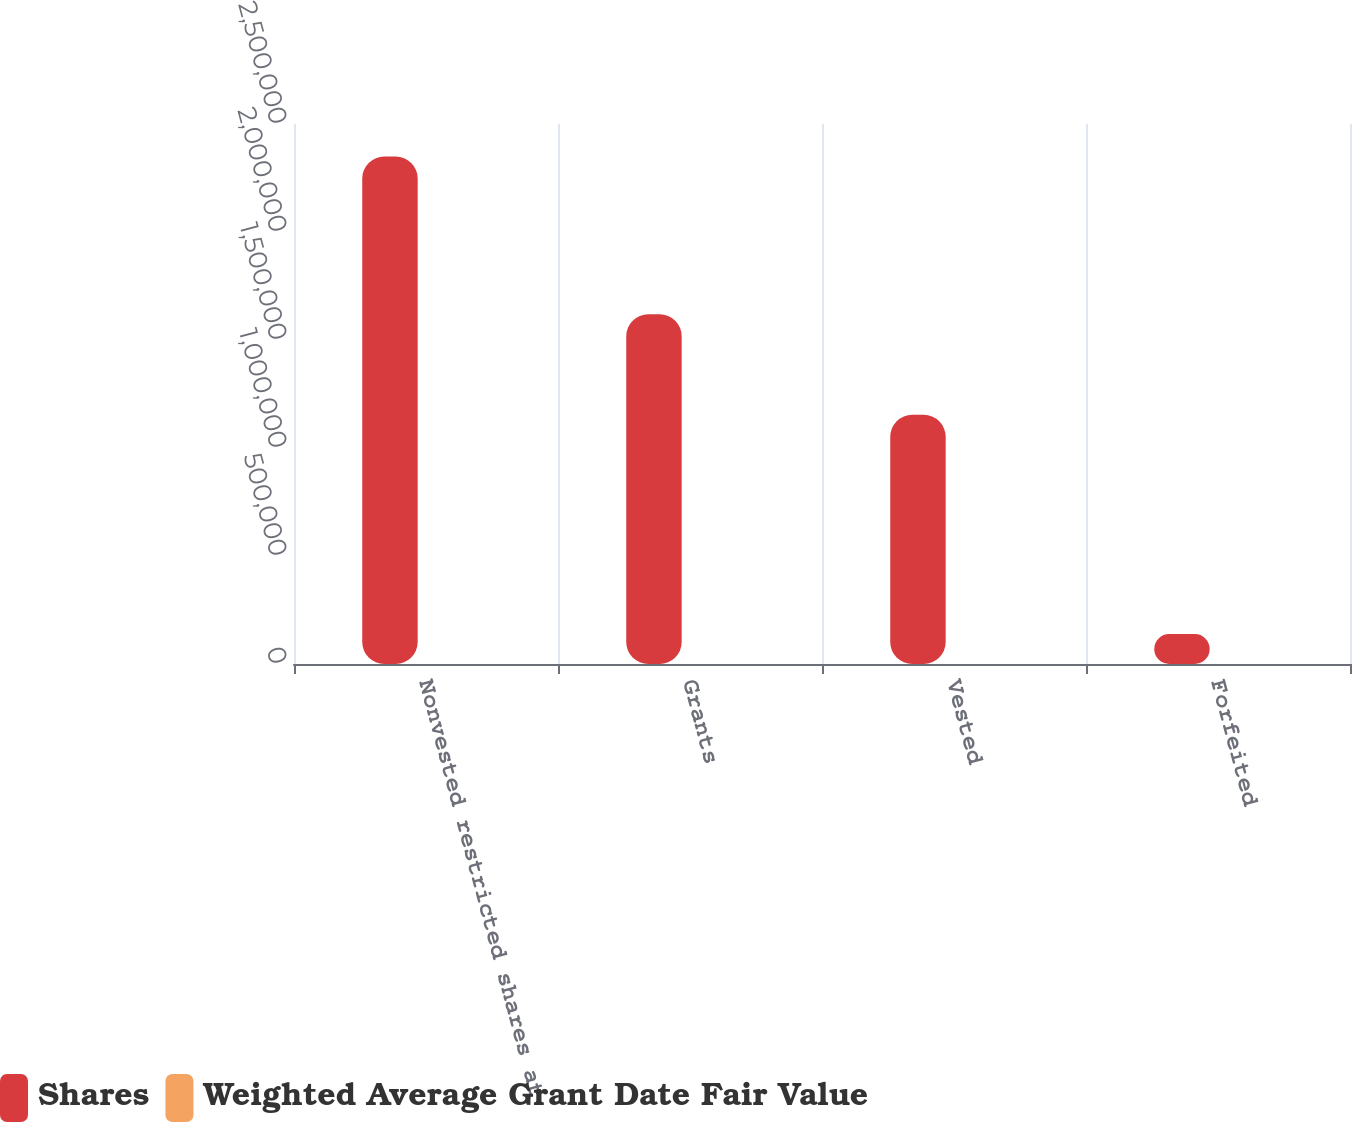Convert chart to OTSL. <chart><loc_0><loc_0><loc_500><loc_500><stacked_bar_chart><ecel><fcel>Nonvested restricted shares at<fcel>Grants<fcel>Vested<fcel>Forfeited<nl><fcel>Shares<fcel>2.34948e+06<fcel>1.61906e+06<fcel>1.15357e+06<fcel>138924<nl><fcel>Weighted Average Grant Date Fair Value<fcel>13.27<fcel>12.63<fcel>22.64<fcel>10.8<nl></chart> 